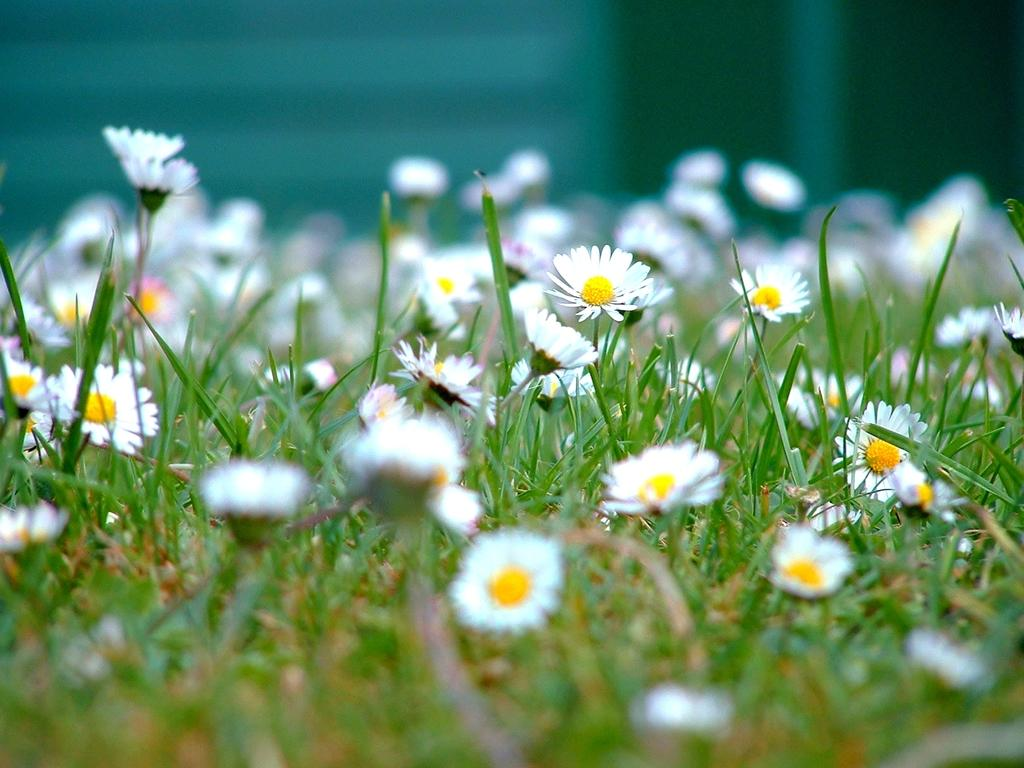What type of flowers can be seen in the image? There are white-colored flowers in the image. Where are the flowers located? The flowers are present on plants. What type of spoon is used to serve the meal in the image? There is no spoon or meal present in the image; it only features white-colored flowers on plants. 